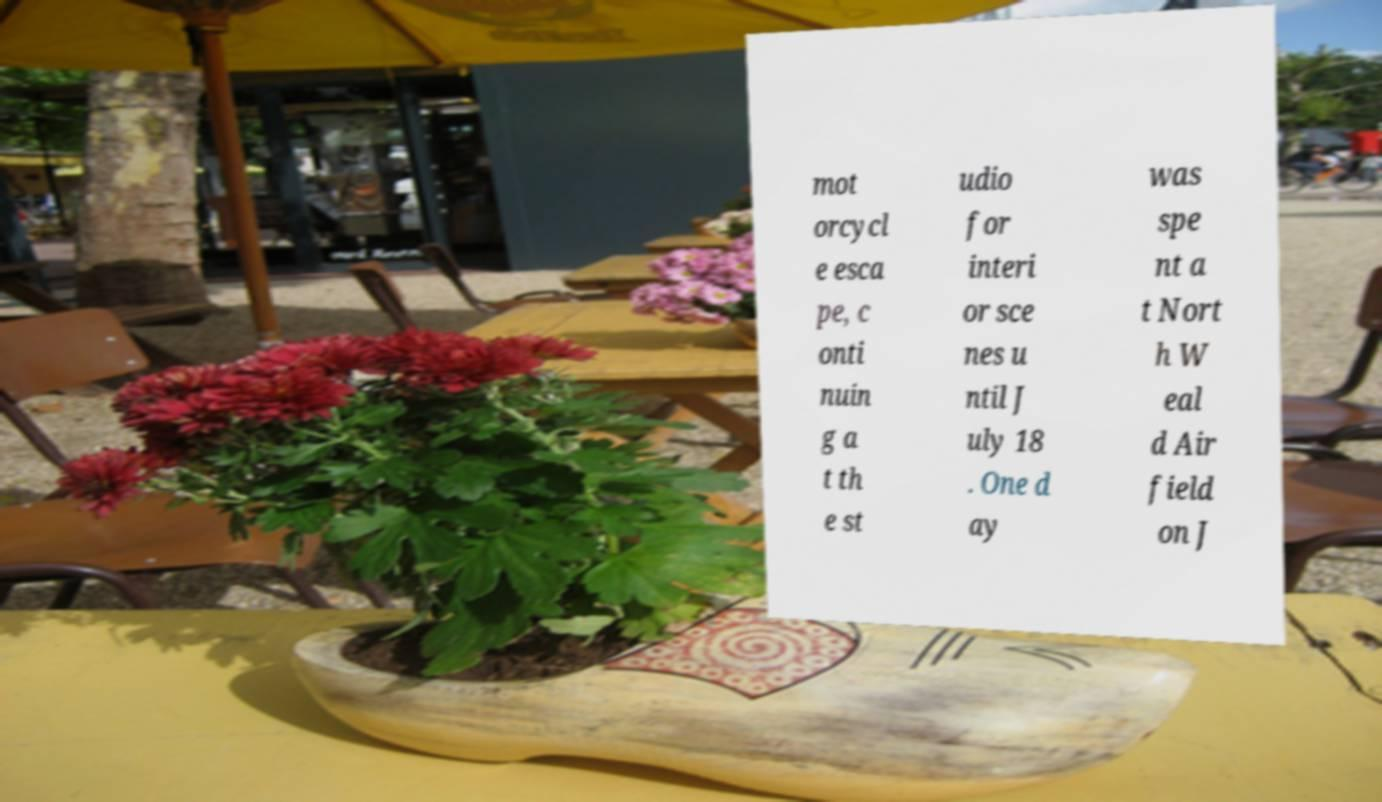There's text embedded in this image that I need extracted. Can you transcribe it verbatim? mot orcycl e esca pe, c onti nuin g a t th e st udio for interi or sce nes u ntil J uly 18 . One d ay was spe nt a t Nort h W eal d Air field on J 